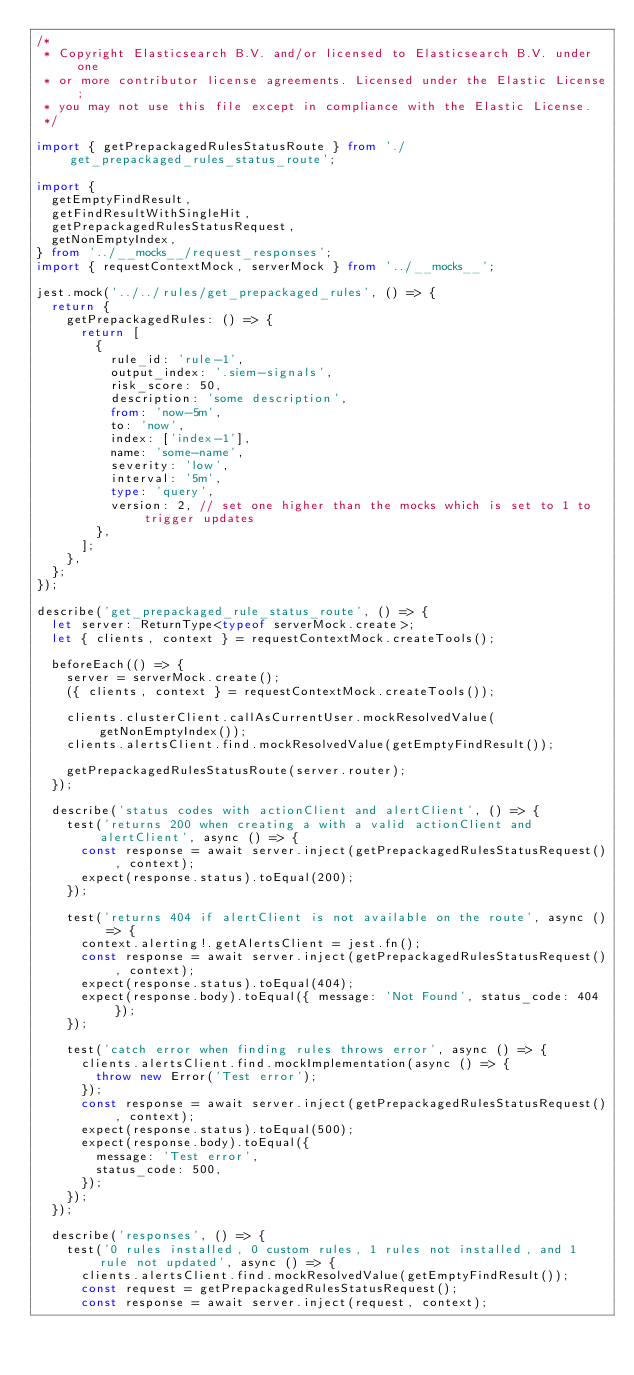Convert code to text. <code><loc_0><loc_0><loc_500><loc_500><_TypeScript_>/*
 * Copyright Elasticsearch B.V. and/or licensed to Elasticsearch B.V. under one
 * or more contributor license agreements. Licensed under the Elastic License;
 * you may not use this file except in compliance with the Elastic License.
 */

import { getPrepackagedRulesStatusRoute } from './get_prepackaged_rules_status_route';

import {
  getEmptyFindResult,
  getFindResultWithSingleHit,
  getPrepackagedRulesStatusRequest,
  getNonEmptyIndex,
} from '../__mocks__/request_responses';
import { requestContextMock, serverMock } from '../__mocks__';

jest.mock('../../rules/get_prepackaged_rules', () => {
  return {
    getPrepackagedRules: () => {
      return [
        {
          rule_id: 'rule-1',
          output_index: '.siem-signals',
          risk_score: 50,
          description: 'some description',
          from: 'now-5m',
          to: 'now',
          index: ['index-1'],
          name: 'some-name',
          severity: 'low',
          interval: '5m',
          type: 'query',
          version: 2, // set one higher than the mocks which is set to 1 to trigger updates
        },
      ];
    },
  };
});

describe('get_prepackaged_rule_status_route', () => {
  let server: ReturnType<typeof serverMock.create>;
  let { clients, context } = requestContextMock.createTools();

  beforeEach(() => {
    server = serverMock.create();
    ({ clients, context } = requestContextMock.createTools());

    clients.clusterClient.callAsCurrentUser.mockResolvedValue(getNonEmptyIndex());
    clients.alertsClient.find.mockResolvedValue(getEmptyFindResult());

    getPrepackagedRulesStatusRoute(server.router);
  });

  describe('status codes with actionClient and alertClient', () => {
    test('returns 200 when creating a with a valid actionClient and alertClient', async () => {
      const response = await server.inject(getPrepackagedRulesStatusRequest(), context);
      expect(response.status).toEqual(200);
    });

    test('returns 404 if alertClient is not available on the route', async () => {
      context.alerting!.getAlertsClient = jest.fn();
      const response = await server.inject(getPrepackagedRulesStatusRequest(), context);
      expect(response.status).toEqual(404);
      expect(response.body).toEqual({ message: 'Not Found', status_code: 404 });
    });

    test('catch error when finding rules throws error', async () => {
      clients.alertsClient.find.mockImplementation(async () => {
        throw new Error('Test error');
      });
      const response = await server.inject(getPrepackagedRulesStatusRequest(), context);
      expect(response.status).toEqual(500);
      expect(response.body).toEqual({
        message: 'Test error',
        status_code: 500,
      });
    });
  });

  describe('responses', () => {
    test('0 rules installed, 0 custom rules, 1 rules not installed, and 1 rule not updated', async () => {
      clients.alertsClient.find.mockResolvedValue(getEmptyFindResult());
      const request = getPrepackagedRulesStatusRequest();
      const response = await server.inject(request, context);
</code> 